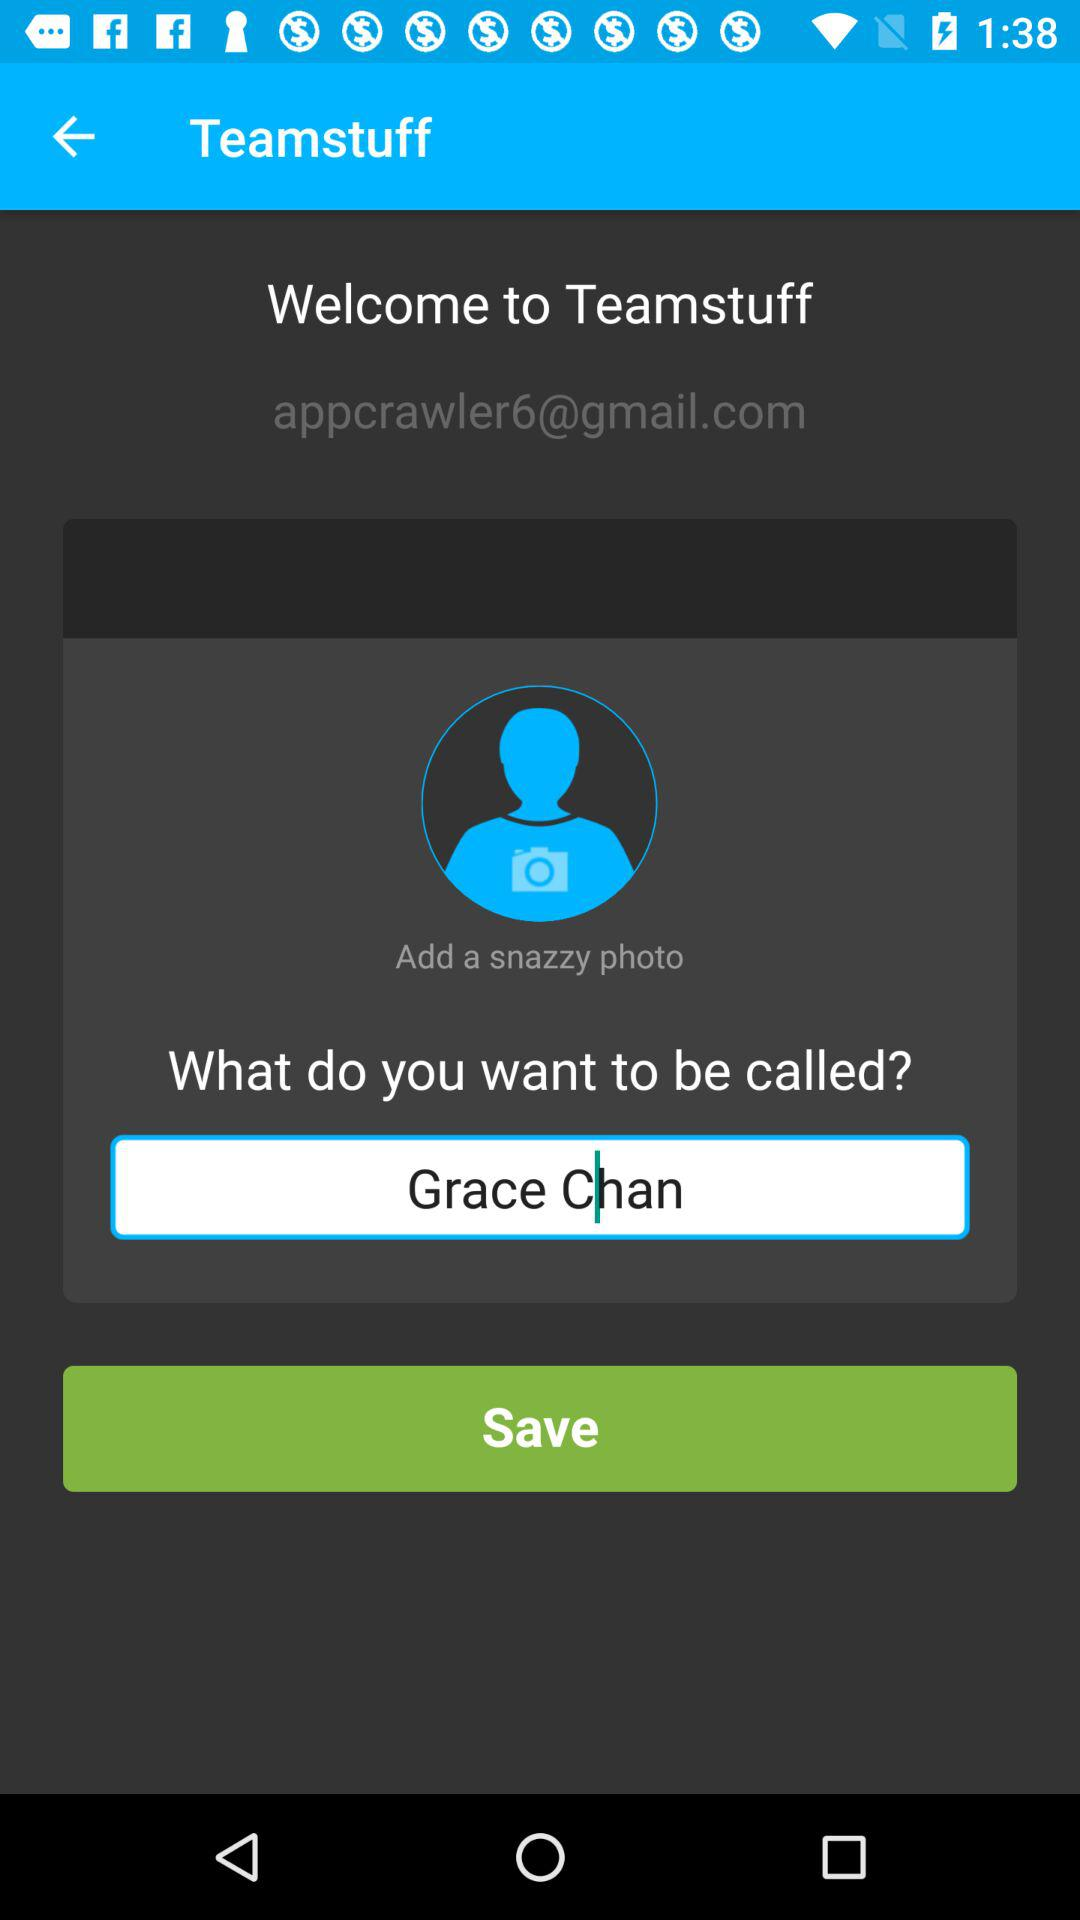What is the email address? The email address is appcrawler6@gmail.com. 